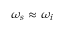<formula> <loc_0><loc_0><loc_500><loc_500>\omega _ { s } \approx \omega _ { i }</formula> 